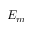Convert formula to latex. <formula><loc_0><loc_0><loc_500><loc_500>E _ { m }</formula> 